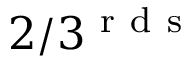<formula> <loc_0><loc_0><loc_500><loc_500>2 / 3 ^ { r d s }</formula> 